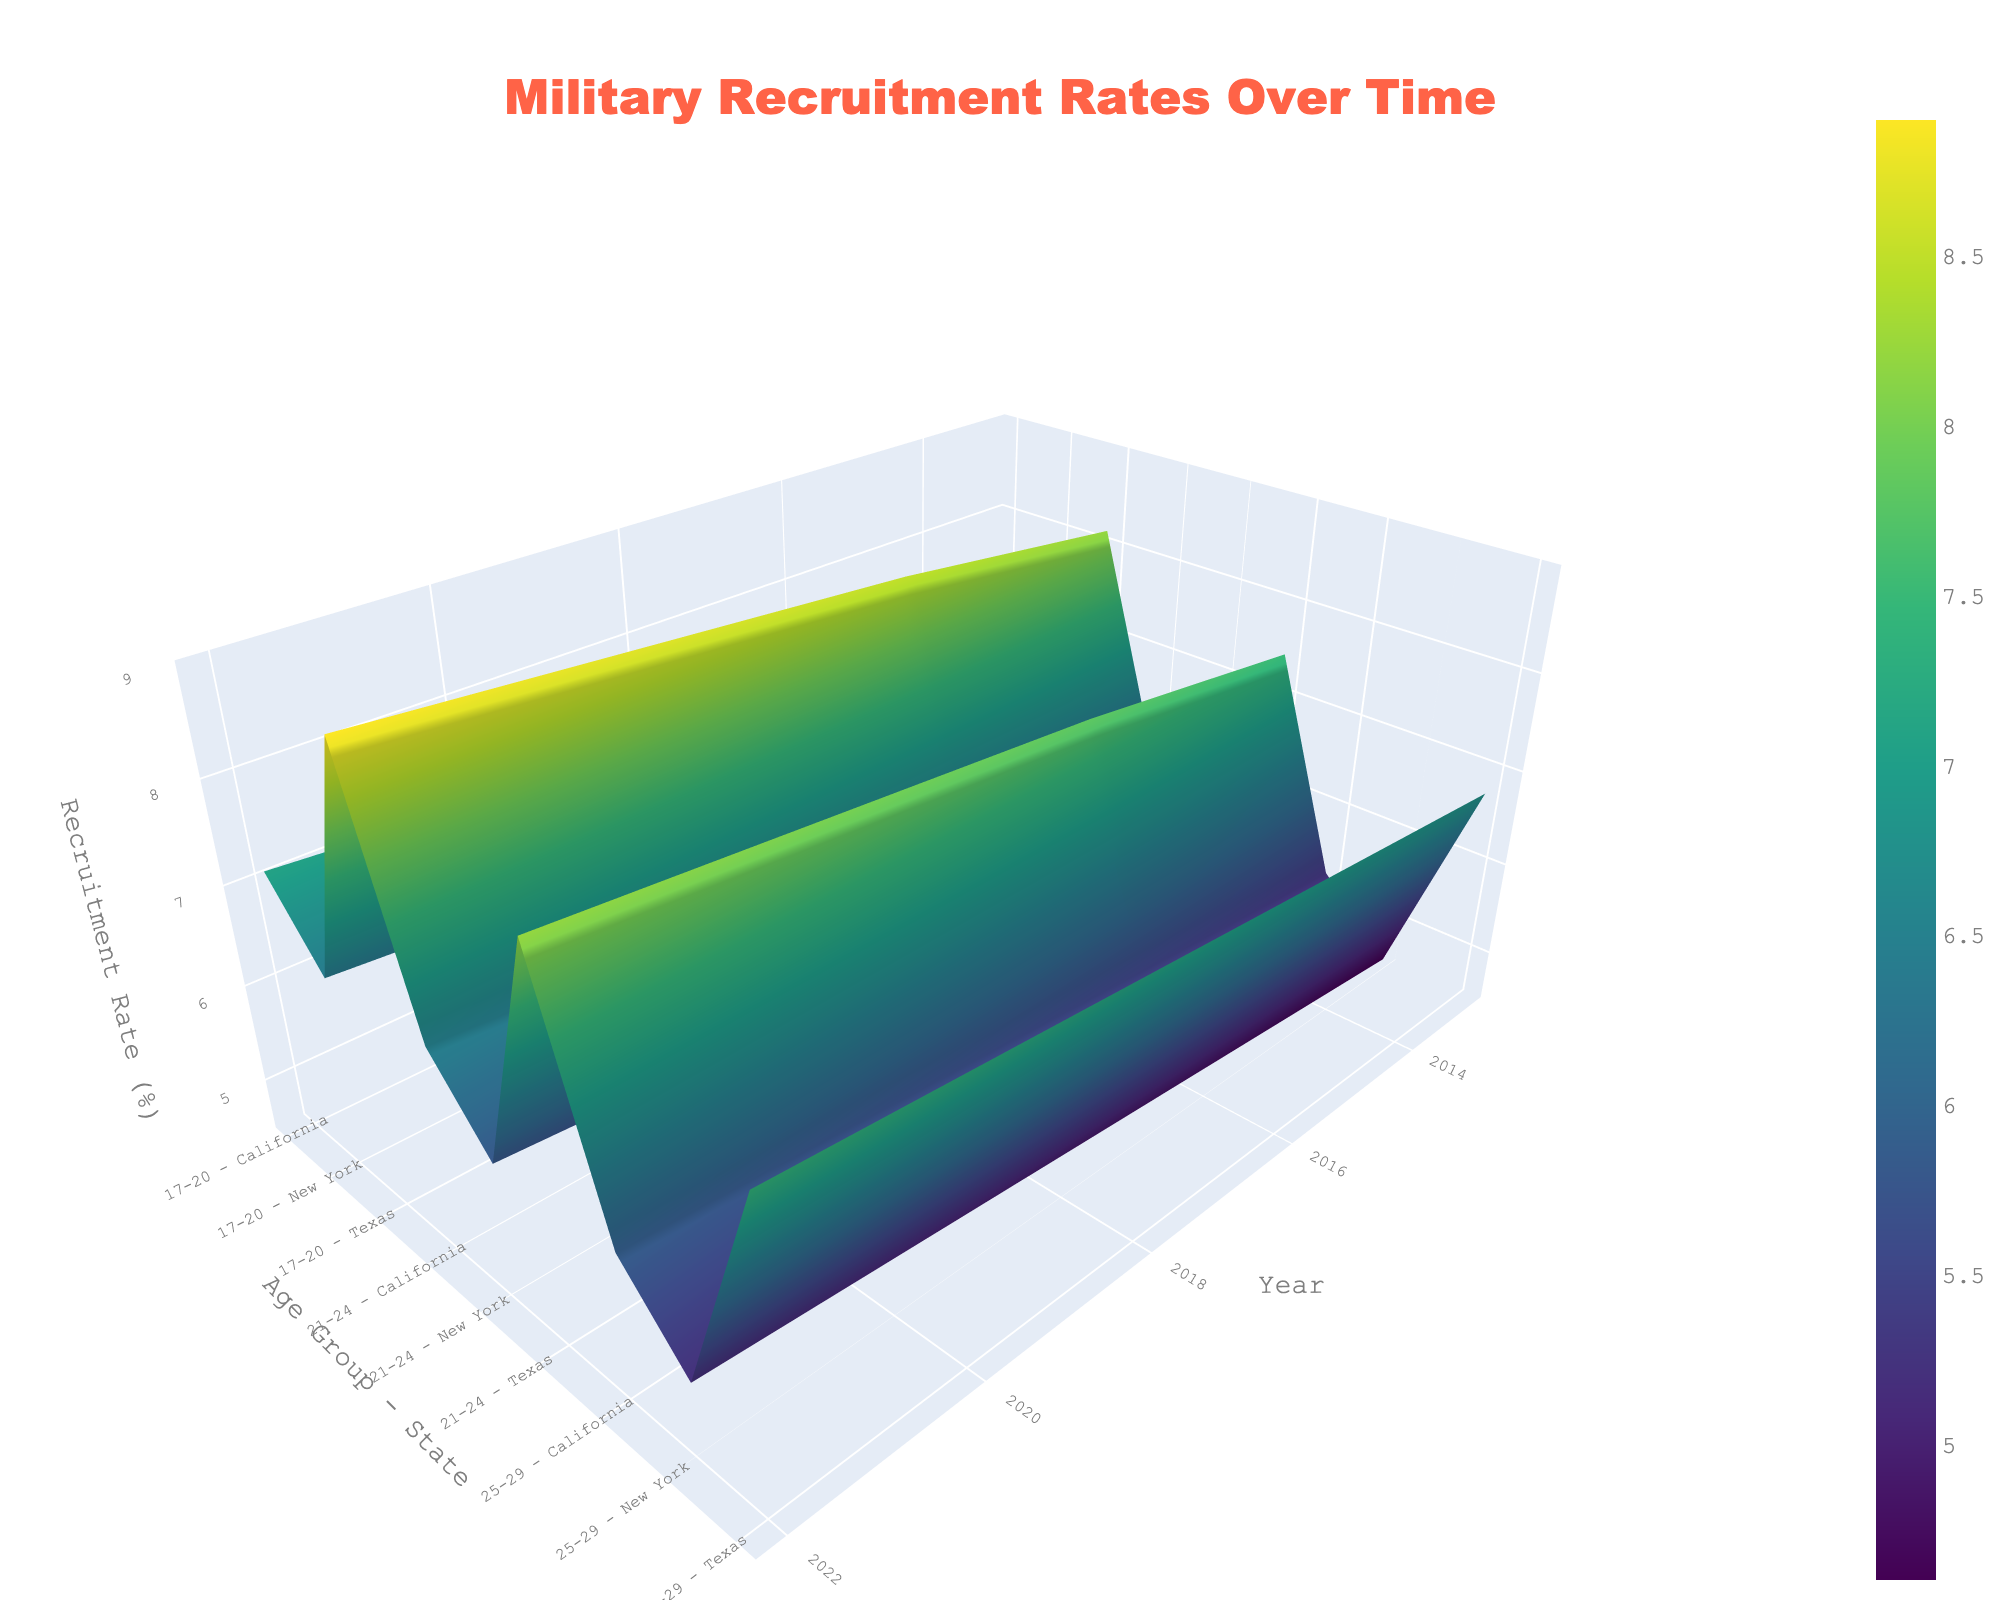What is the title of the 3D surface plot? The title is clearly displayed at the top center of the plot in a large, bold font. It reads, "Military Recruitment Rates Over Time."
Answer: Military Recruitment Rates Over Time What does the z-axis represent in the plot? The z-axis title is shown on the right side of the plot. It reads "Recruitment Rate (%)," indicating that the z-axis shows the percentage of recruitment rates.
Answer: Recruitment Rate (%) Which age group and state have the highest recruitment rate in 2022? By examining the data points and values in the plot for the year 2022, we can observe that the highest recruitment rate is for the 17-20 age group in Texas, with a rate of 8.9%.
Answer: 17-20 in Texas How did the recruitment rate for the 17-20 age group in California change from 2013 to 2022? By following the surface plot lines corresponding to California's 17-20 age group from 2013 to 2022, the recruitment rate increased from 6.5% in 2013 to 7.1% in 2022.
Answer: Increased from 6.5% to 7.1% What are the three states displayed in the figure? The y-axis labels include age groups and state names. The three states displayed are Texas, California, and New York.
Answer: Texas, California, and New York For which state did the 25-29 age group show the most significant increase in recruitment rates from 2013 to 2022? By examining the surface plot for the 25-29 age group across different states from 2013 to 2022, Texas shows the most significant increase from 6.8% to 7.4%.
Answer: Texas Which age group in New York had the lowest recruitment rate in 2013? By looking at the data points in the plot for New York in 2013, the 25-29 age group had the lowest recruitment rate of 4.6%.
Answer: 25-29 How does the recruitment rate in the 21-24 age group in Texas in 2013 compare to that in 2019? By comparing the data points for the 21-24 age group in Texas between 2013 and 2019, the recruitment rate increased from 7.5% to 8.0%.
Answer: Increased from 7.5% to 8.0% What trend do you observe for the recruitment rates over the past decade in all states? Observing the surface plot as a whole, recruitment rates show a general increasing trend over the past decade across all age groups and states.
Answer: Increasing trend 